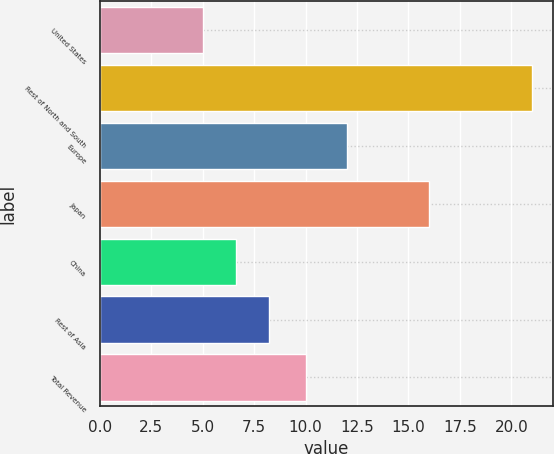Convert chart to OTSL. <chart><loc_0><loc_0><loc_500><loc_500><bar_chart><fcel>United States<fcel>Rest of North and South<fcel>Europe<fcel>Japan<fcel>China<fcel>Rest of Asia<fcel>Total Revenue<nl><fcel>5<fcel>21<fcel>12<fcel>16<fcel>6.6<fcel>8.2<fcel>10<nl></chart> 